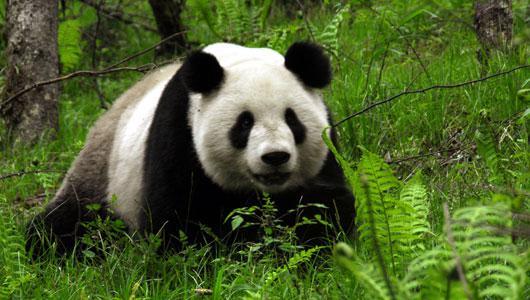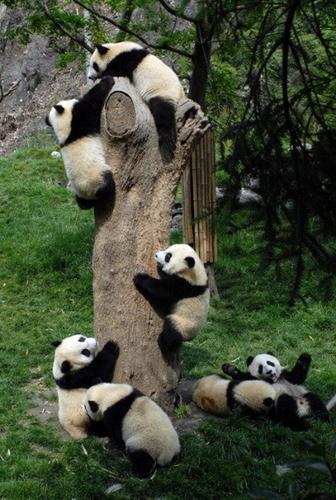The first image is the image on the left, the second image is the image on the right. Analyze the images presented: Is the assertion "There are at least six pandas." valid? Answer yes or no. Yes. The first image is the image on the left, the second image is the image on the right. Considering the images on both sides, is "An image shows exactly one panda, which is sitting and nibbling on a leafy stalk." valid? Answer yes or no. No. 